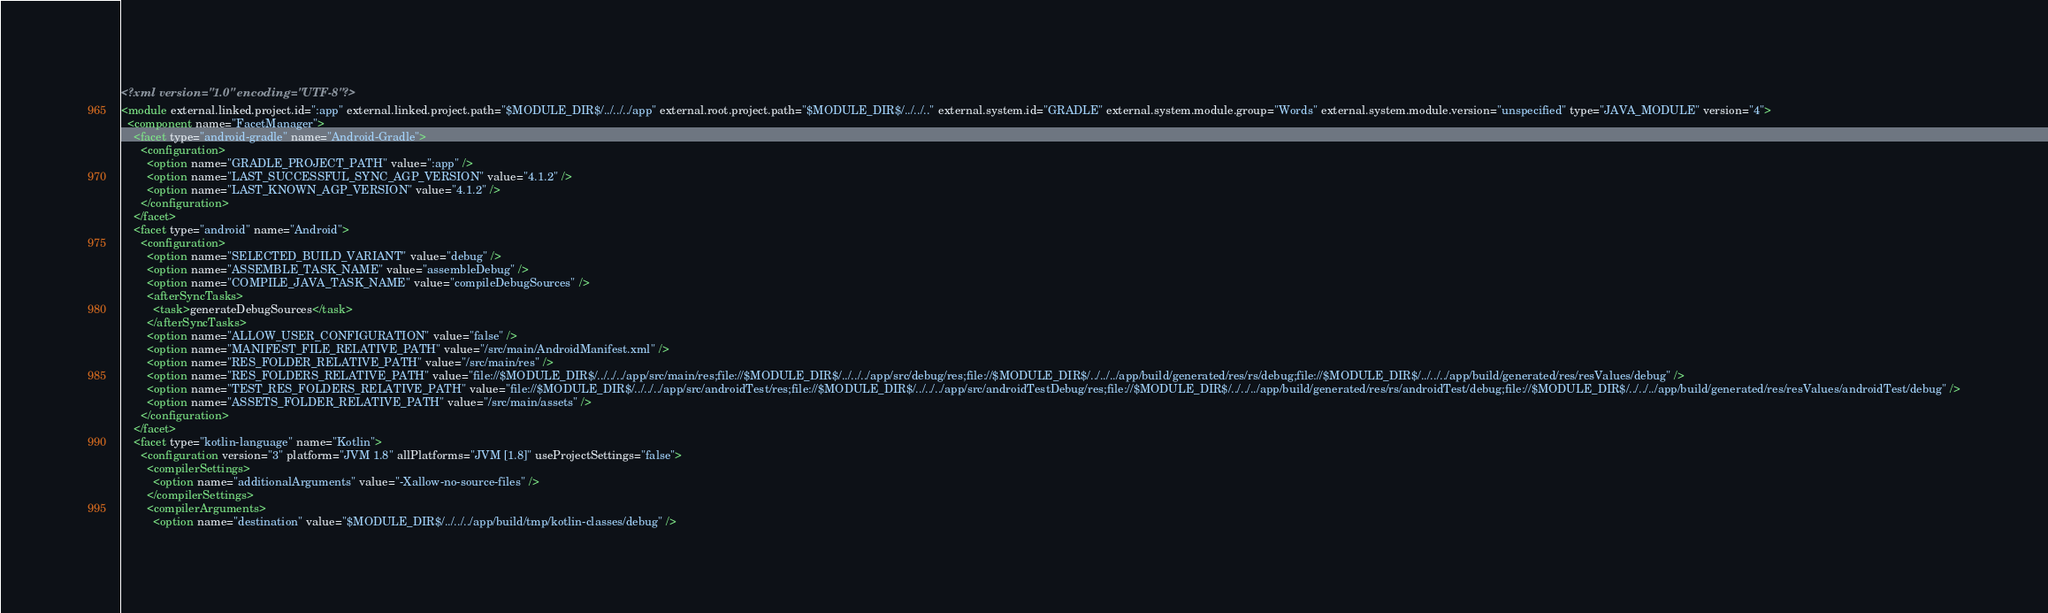Convert code to text. <code><loc_0><loc_0><loc_500><loc_500><_XML_><?xml version="1.0" encoding="UTF-8"?>
<module external.linked.project.id=":app" external.linked.project.path="$MODULE_DIR$/../../../app" external.root.project.path="$MODULE_DIR$/../../.." external.system.id="GRADLE" external.system.module.group="Words" external.system.module.version="unspecified" type="JAVA_MODULE" version="4">
  <component name="FacetManager">
    <facet type="android-gradle" name="Android-Gradle">
      <configuration>
        <option name="GRADLE_PROJECT_PATH" value=":app" />
        <option name="LAST_SUCCESSFUL_SYNC_AGP_VERSION" value="4.1.2" />
        <option name="LAST_KNOWN_AGP_VERSION" value="4.1.2" />
      </configuration>
    </facet>
    <facet type="android" name="Android">
      <configuration>
        <option name="SELECTED_BUILD_VARIANT" value="debug" />
        <option name="ASSEMBLE_TASK_NAME" value="assembleDebug" />
        <option name="COMPILE_JAVA_TASK_NAME" value="compileDebugSources" />
        <afterSyncTasks>
          <task>generateDebugSources</task>
        </afterSyncTasks>
        <option name="ALLOW_USER_CONFIGURATION" value="false" />
        <option name="MANIFEST_FILE_RELATIVE_PATH" value="/src/main/AndroidManifest.xml" />
        <option name="RES_FOLDER_RELATIVE_PATH" value="/src/main/res" />
        <option name="RES_FOLDERS_RELATIVE_PATH" value="file://$MODULE_DIR$/../../../app/src/main/res;file://$MODULE_DIR$/../../../app/src/debug/res;file://$MODULE_DIR$/../../../app/build/generated/res/rs/debug;file://$MODULE_DIR$/../../../app/build/generated/res/resValues/debug" />
        <option name="TEST_RES_FOLDERS_RELATIVE_PATH" value="file://$MODULE_DIR$/../../../app/src/androidTest/res;file://$MODULE_DIR$/../../../app/src/androidTestDebug/res;file://$MODULE_DIR$/../../../app/build/generated/res/rs/androidTest/debug;file://$MODULE_DIR$/../../../app/build/generated/res/resValues/androidTest/debug" />
        <option name="ASSETS_FOLDER_RELATIVE_PATH" value="/src/main/assets" />
      </configuration>
    </facet>
    <facet type="kotlin-language" name="Kotlin">
      <configuration version="3" platform="JVM 1.8" allPlatforms="JVM [1.8]" useProjectSettings="false">
        <compilerSettings>
          <option name="additionalArguments" value="-Xallow-no-source-files" />
        </compilerSettings>
        <compilerArguments>
          <option name="destination" value="$MODULE_DIR$/../../../app/build/tmp/kotlin-classes/debug" /></code> 